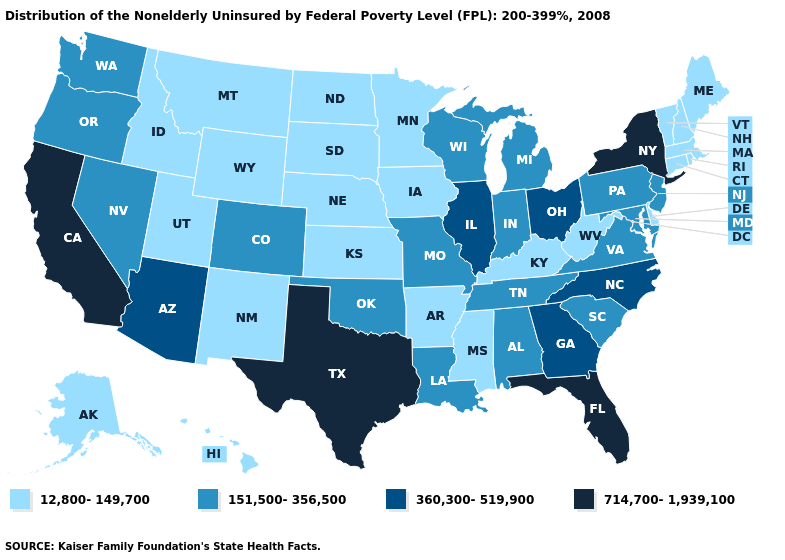What is the highest value in the USA?
Short answer required. 714,700-1,939,100. What is the value of Minnesota?
Short answer required. 12,800-149,700. What is the value of Georgia?
Give a very brief answer. 360,300-519,900. Does New Hampshire have the lowest value in the USA?
Answer briefly. Yes. Does the map have missing data?
Write a very short answer. No. What is the lowest value in the West?
Short answer required. 12,800-149,700. Which states have the lowest value in the USA?
Keep it brief. Alaska, Arkansas, Connecticut, Delaware, Hawaii, Idaho, Iowa, Kansas, Kentucky, Maine, Massachusetts, Minnesota, Mississippi, Montana, Nebraska, New Hampshire, New Mexico, North Dakota, Rhode Island, South Dakota, Utah, Vermont, West Virginia, Wyoming. What is the value of Florida?
Keep it brief. 714,700-1,939,100. How many symbols are there in the legend?
Be succinct. 4. Is the legend a continuous bar?
Keep it brief. No. Name the states that have a value in the range 151,500-356,500?
Answer briefly. Alabama, Colorado, Indiana, Louisiana, Maryland, Michigan, Missouri, Nevada, New Jersey, Oklahoma, Oregon, Pennsylvania, South Carolina, Tennessee, Virginia, Washington, Wisconsin. What is the value of New Jersey?
Be succinct. 151,500-356,500. Name the states that have a value in the range 714,700-1,939,100?
Concise answer only. California, Florida, New York, Texas. Name the states that have a value in the range 714,700-1,939,100?
Concise answer only. California, Florida, New York, Texas. 